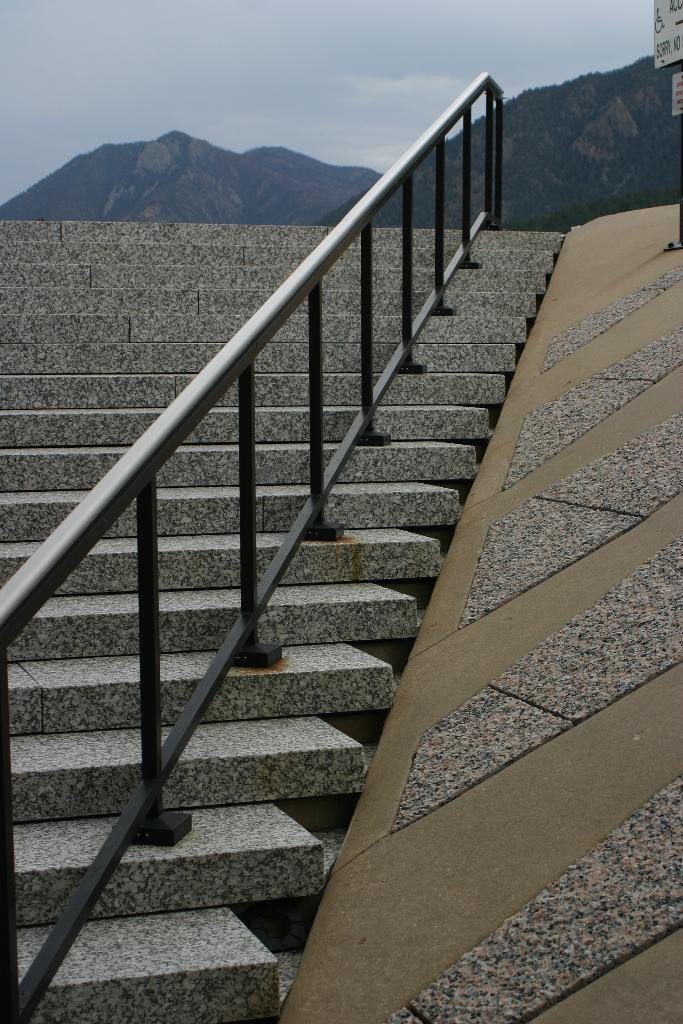What type of architectural feature is present in the image? There are stairs in the image. What safety feature is included with the stairs? There are railings in the image. What type of natural landscape can be seen in the background of the image? Hills are visible in the background of the image. What is visible in the sky in the image? Clouds are present in the sky in the image. What type of breakfast is being served on the stairs in the image? There is no breakfast present in the image; it only features stairs, railings, hills, and clouds. Can you describe the mother's interaction with the bean in the image? There is no mother or bean present in the image. 